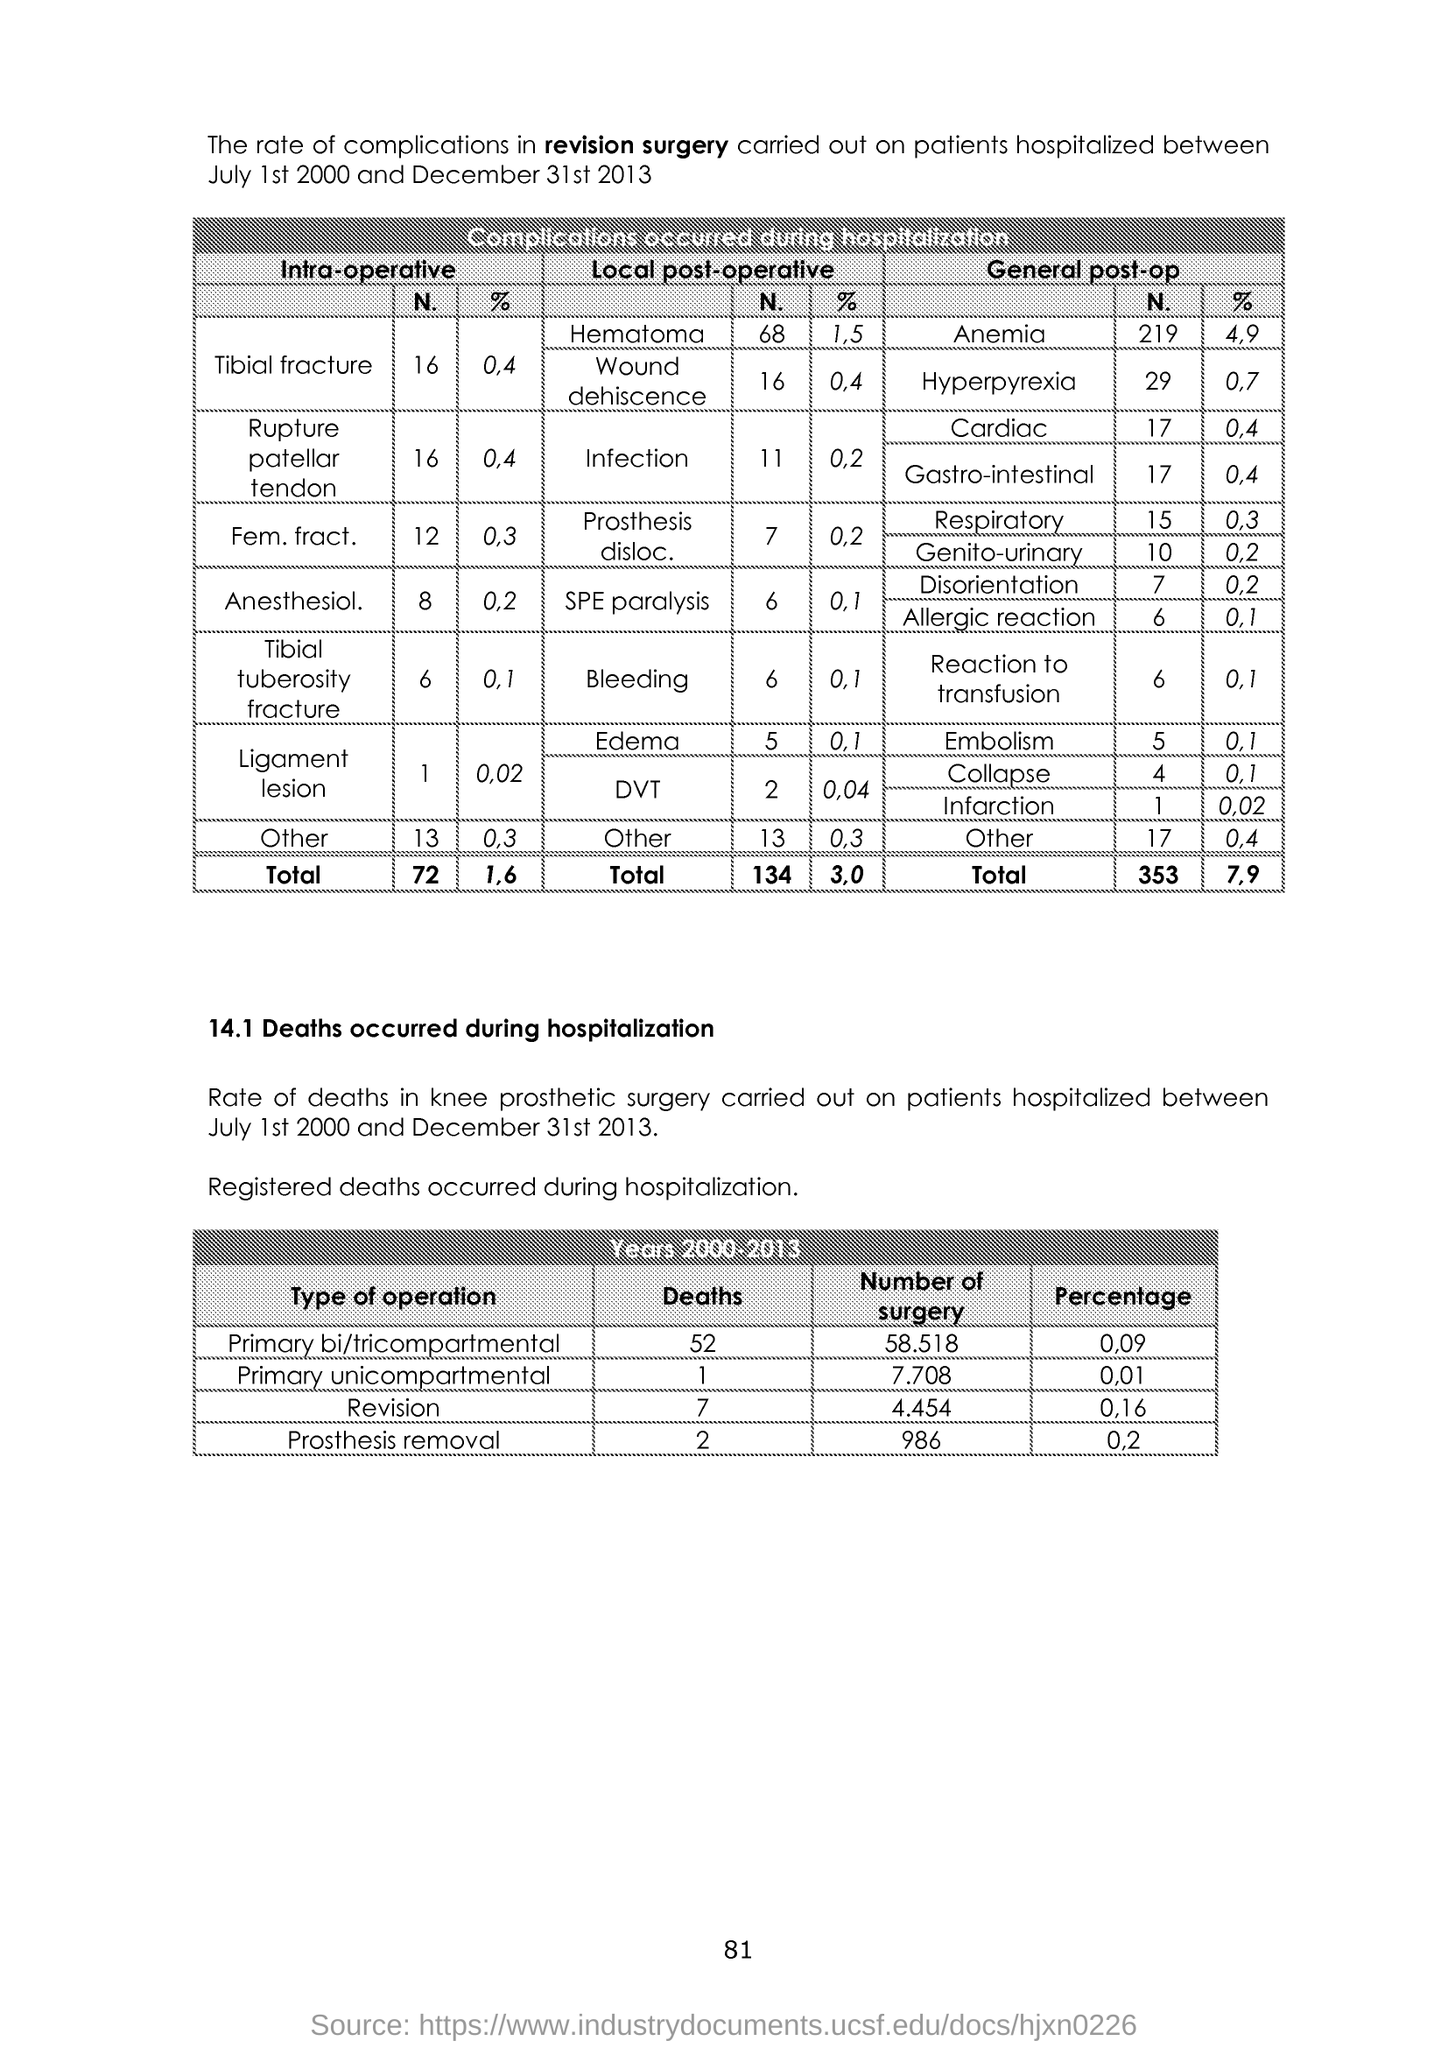What is the title mentioned in 14.1?
Make the answer very short. Deaths occurred during hospitalization. 